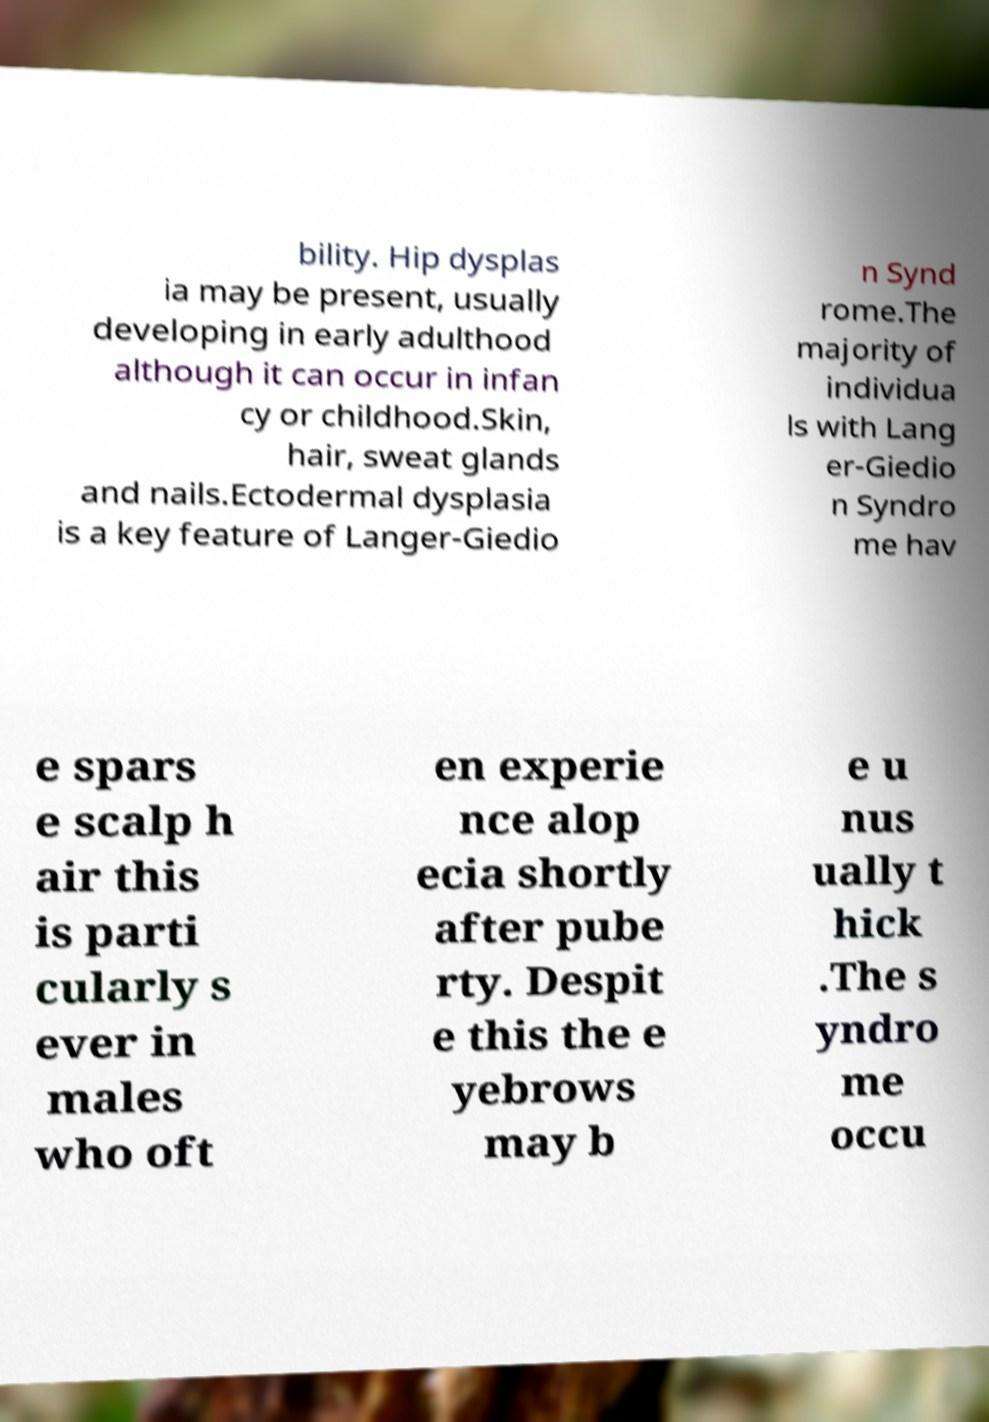Please read and relay the text visible in this image. What does it say? bility. Hip dysplas ia may be present, usually developing in early adulthood although it can occur in infan cy or childhood.Skin, hair, sweat glands and nails.Ectodermal dysplasia is a key feature of Langer-Giedio n Synd rome.The majority of individua ls with Lang er-Giedio n Syndro me hav e spars e scalp h air this is parti cularly s ever in males who oft en experie nce alop ecia shortly after pube rty. Despit e this the e yebrows may b e u nus ually t hick .The s yndro me occu 